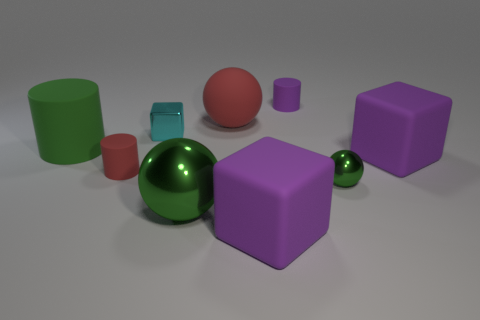What number of other things are there of the same color as the big metallic object?
Keep it short and to the point. 2. How big is the red cylinder?
Give a very brief answer. Small. Is the number of small red rubber cylinders that are in front of the big metallic sphere greater than the number of cyan blocks in front of the small green metallic ball?
Provide a short and direct response. No. How many tiny cyan things are to the left of the cylinder that is in front of the large cylinder?
Provide a short and direct response. 0. Is the shape of the big rubber object in front of the large green metallic thing the same as  the small cyan object?
Provide a succinct answer. Yes. There is a big green object that is the same shape as the tiny green object; what is its material?
Your answer should be very brief. Metal. How many purple blocks are the same size as the rubber ball?
Keep it short and to the point. 2. What is the color of the thing that is both on the right side of the small purple thing and behind the small green metal ball?
Keep it short and to the point. Purple. Is the number of gray cubes less than the number of tiny green balls?
Your answer should be very brief. Yes. Do the large metal object and the cylinder that is to the right of the red sphere have the same color?
Ensure brevity in your answer.  No. 